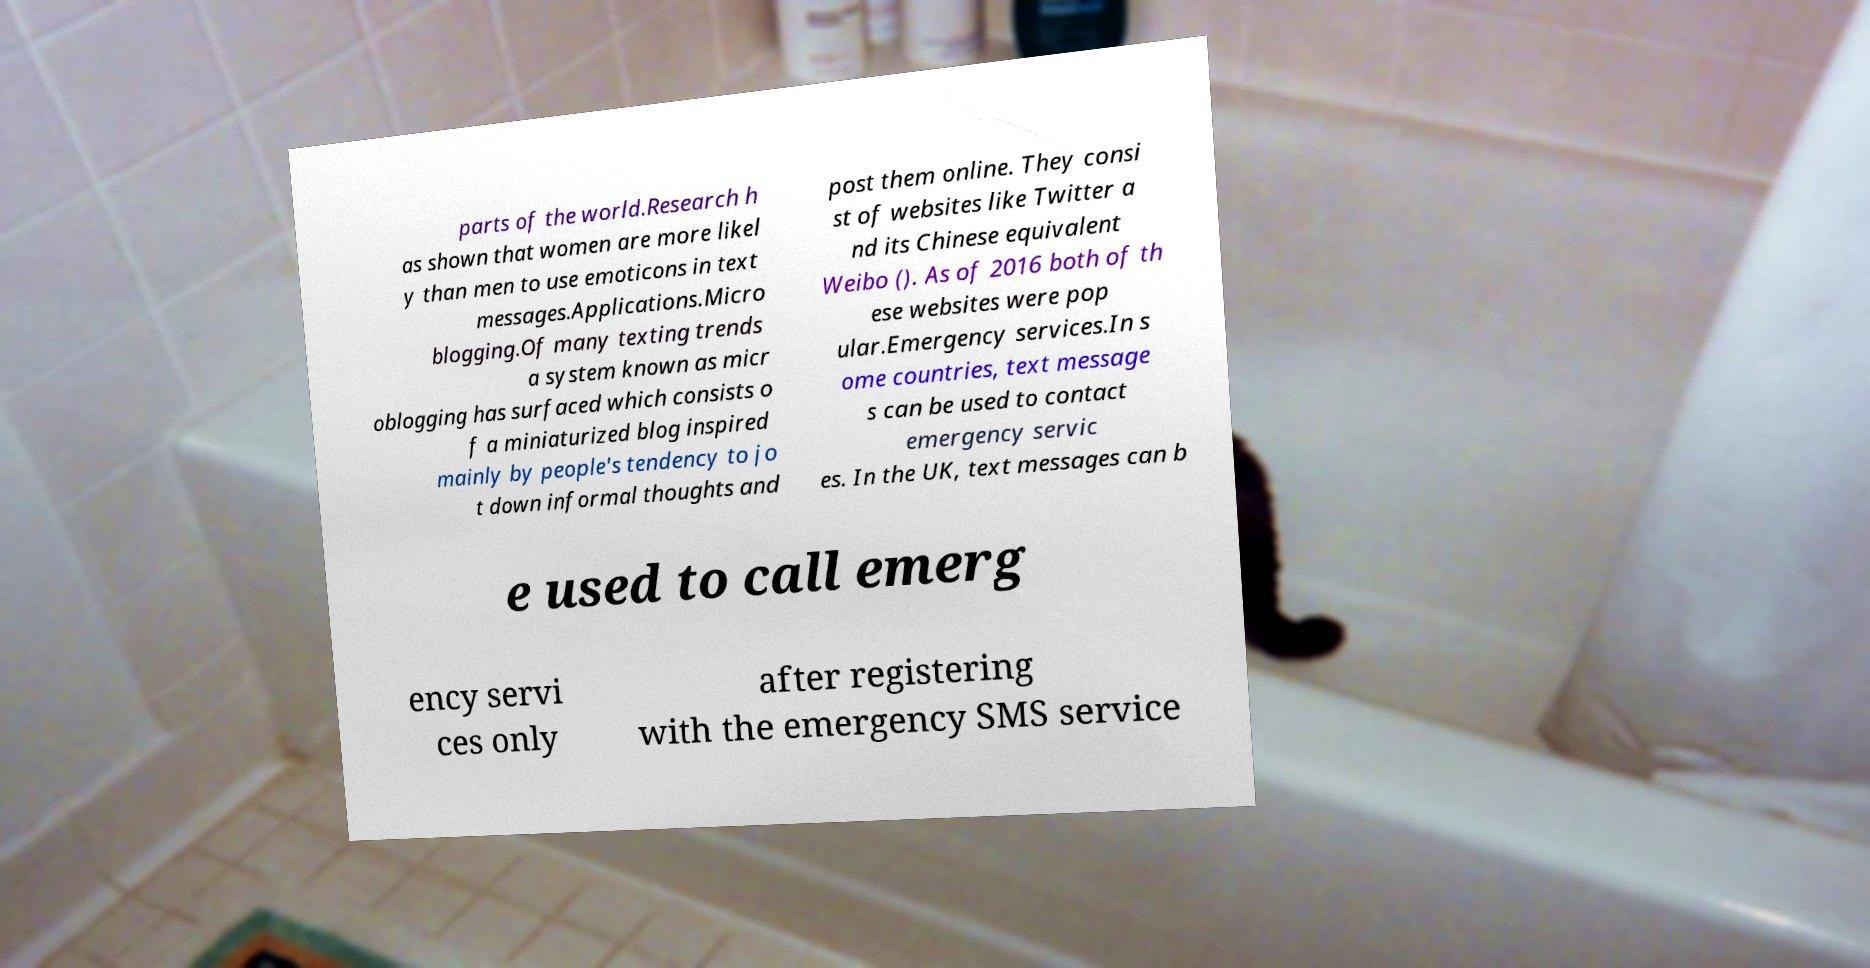There's text embedded in this image that I need extracted. Can you transcribe it verbatim? parts of the world.Research h as shown that women are more likel y than men to use emoticons in text messages.Applications.Micro blogging.Of many texting trends a system known as micr oblogging has surfaced which consists o f a miniaturized blog inspired mainly by people's tendency to jo t down informal thoughts and post them online. They consi st of websites like Twitter a nd its Chinese equivalent Weibo (). As of 2016 both of th ese websites were pop ular.Emergency services.In s ome countries, text message s can be used to contact emergency servic es. In the UK, text messages can b e used to call emerg ency servi ces only after registering with the emergency SMS service 